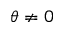<formula> <loc_0><loc_0><loc_500><loc_500>\theta \neq 0</formula> 